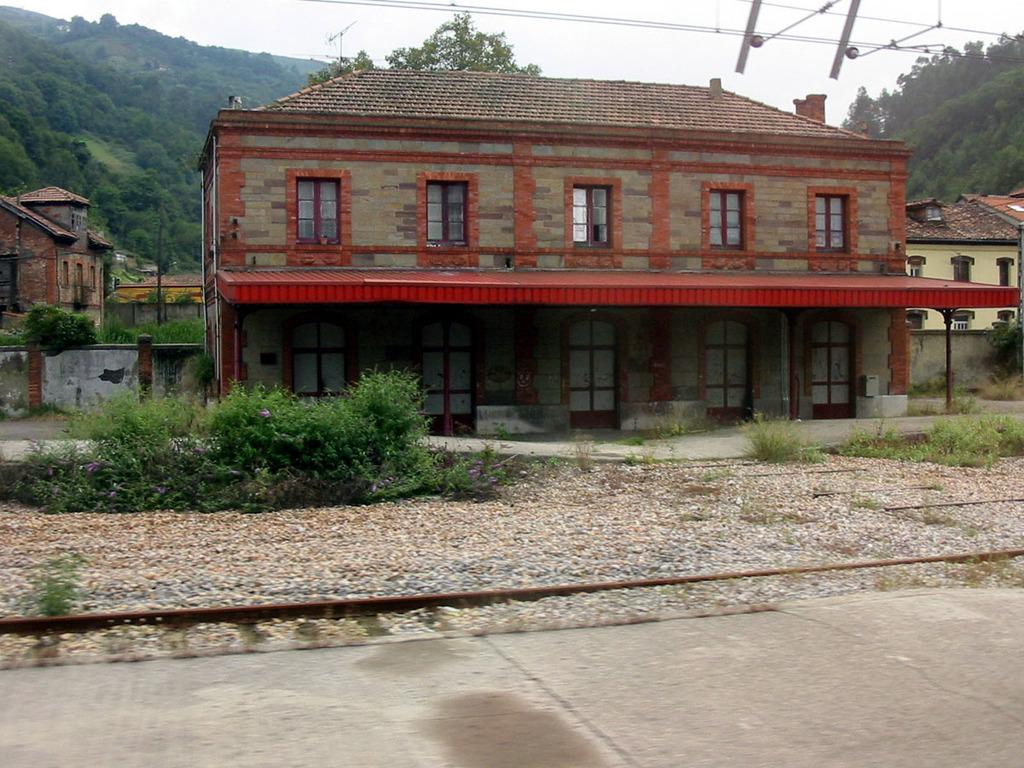What type of vegetation can be seen in the image? There are plants and grass in the image. What type of structures are present in the image? There are buildings in the image. What type of material is present in the image? There are stones and wires in the image. What can be seen in the background of the image? There are trees and sky visible in the background of the image. How many spiders are crawling on the yarn in the image? There is no yarn or spiders present in the image. Can you see a ghost in the image? There is no ghost present in the image. 